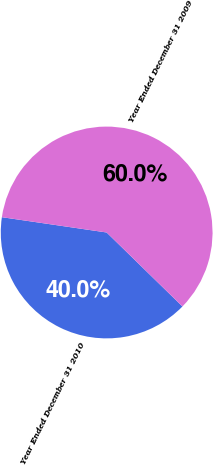<chart> <loc_0><loc_0><loc_500><loc_500><pie_chart><fcel>Year Ended December 31 2010<fcel>Year Ended December 31 2009<nl><fcel>40.0%<fcel>60.0%<nl></chart> 